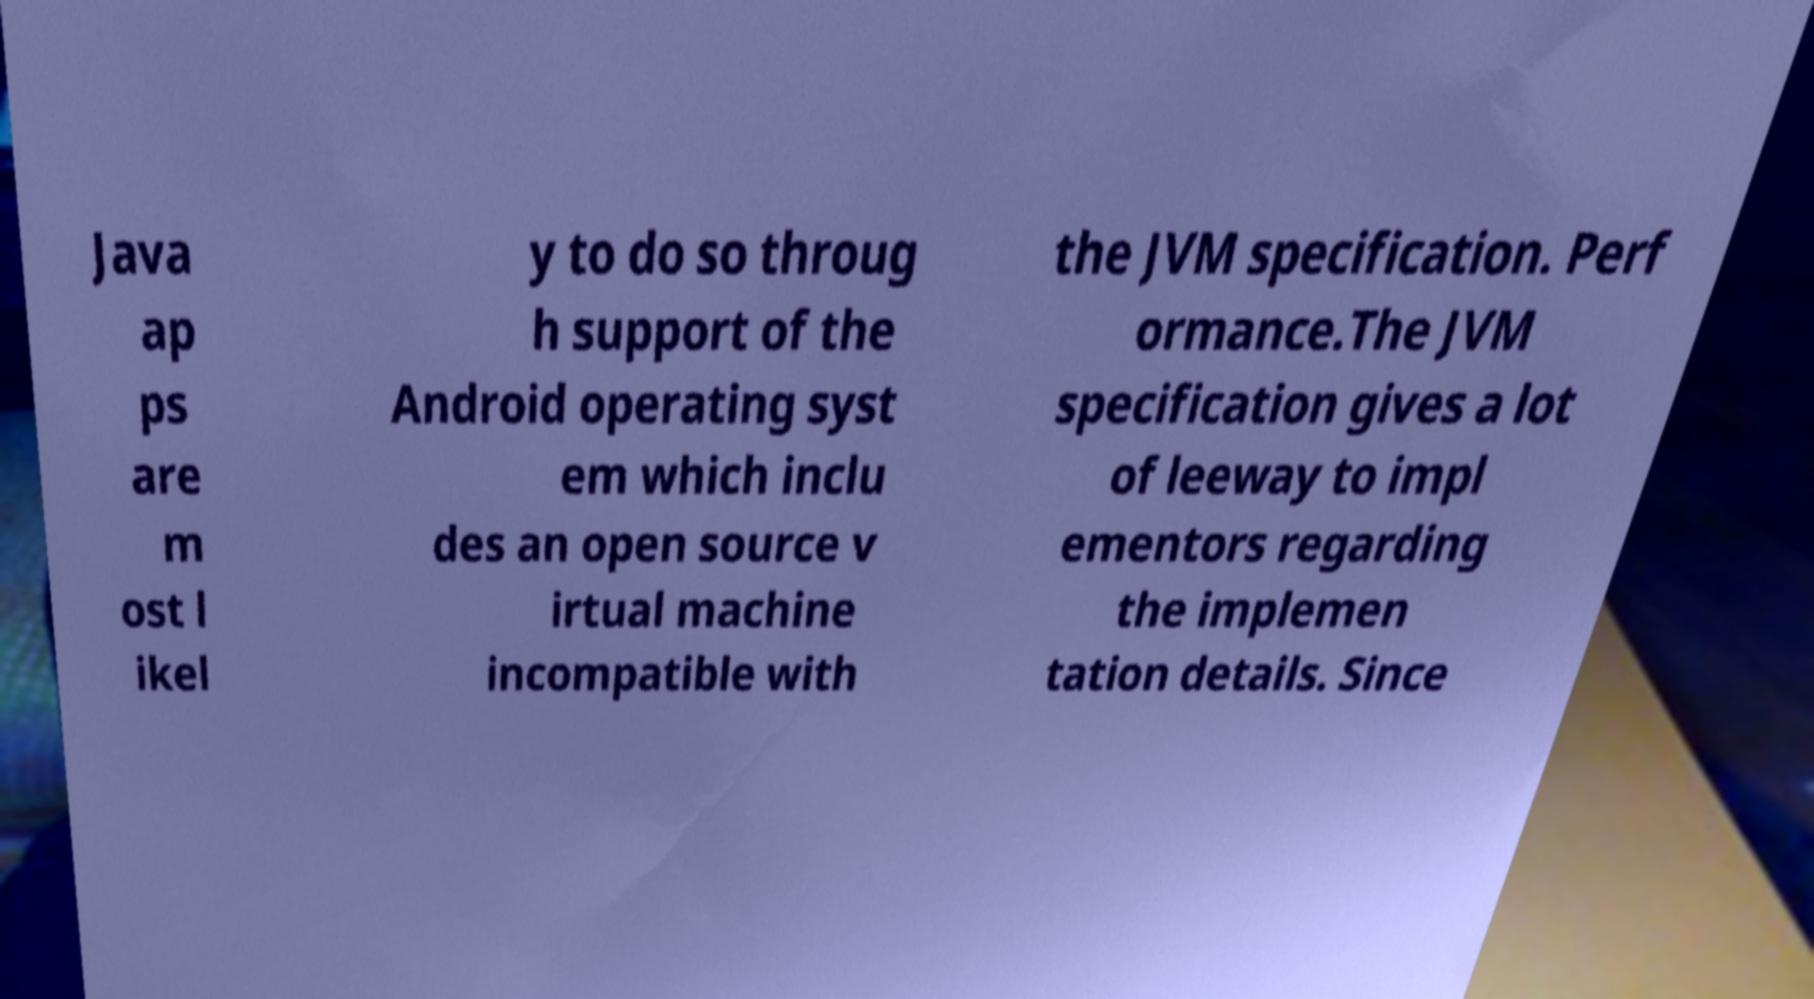There's text embedded in this image that I need extracted. Can you transcribe it verbatim? Java ap ps are m ost l ikel y to do so throug h support of the Android operating syst em which inclu des an open source v irtual machine incompatible with the JVM specification. Perf ormance.The JVM specification gives a lot of leeway to impl ementors regarding the implemen tation details. Since 